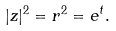Convert formula to latex. <formula><loc_0><loc_0><loc_500><loc_500>| z | ^ { 2 } = r ^ { 2 } = e ^ { t } .</formula> 